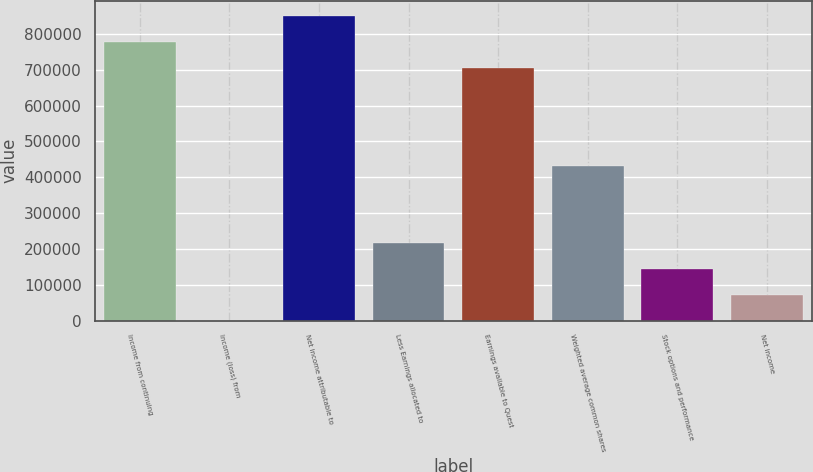<chart> <loc_0><loc_0><loc_500><loc_500><bar_chart><fcel>Income from continuing<fcel>Income (loss) from<fcel>Net income attributable to<fcel>Less Earnings allocated to<fcel>Earnings available to Quest<fcel>Weighted average common shares<fcel>Stock options and performance<fcel>Net income<nl><fcel>777531<fcel>0.07<fcel>849621<fcel>216268<fcel>705442<fcel>432536<fcel>144179<fcel>72089.5<nl></chart> 